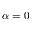Convert formula to latex. <formula><loc_0><loc_0><loc_500><loc_500>\alpha = 0</formula> 